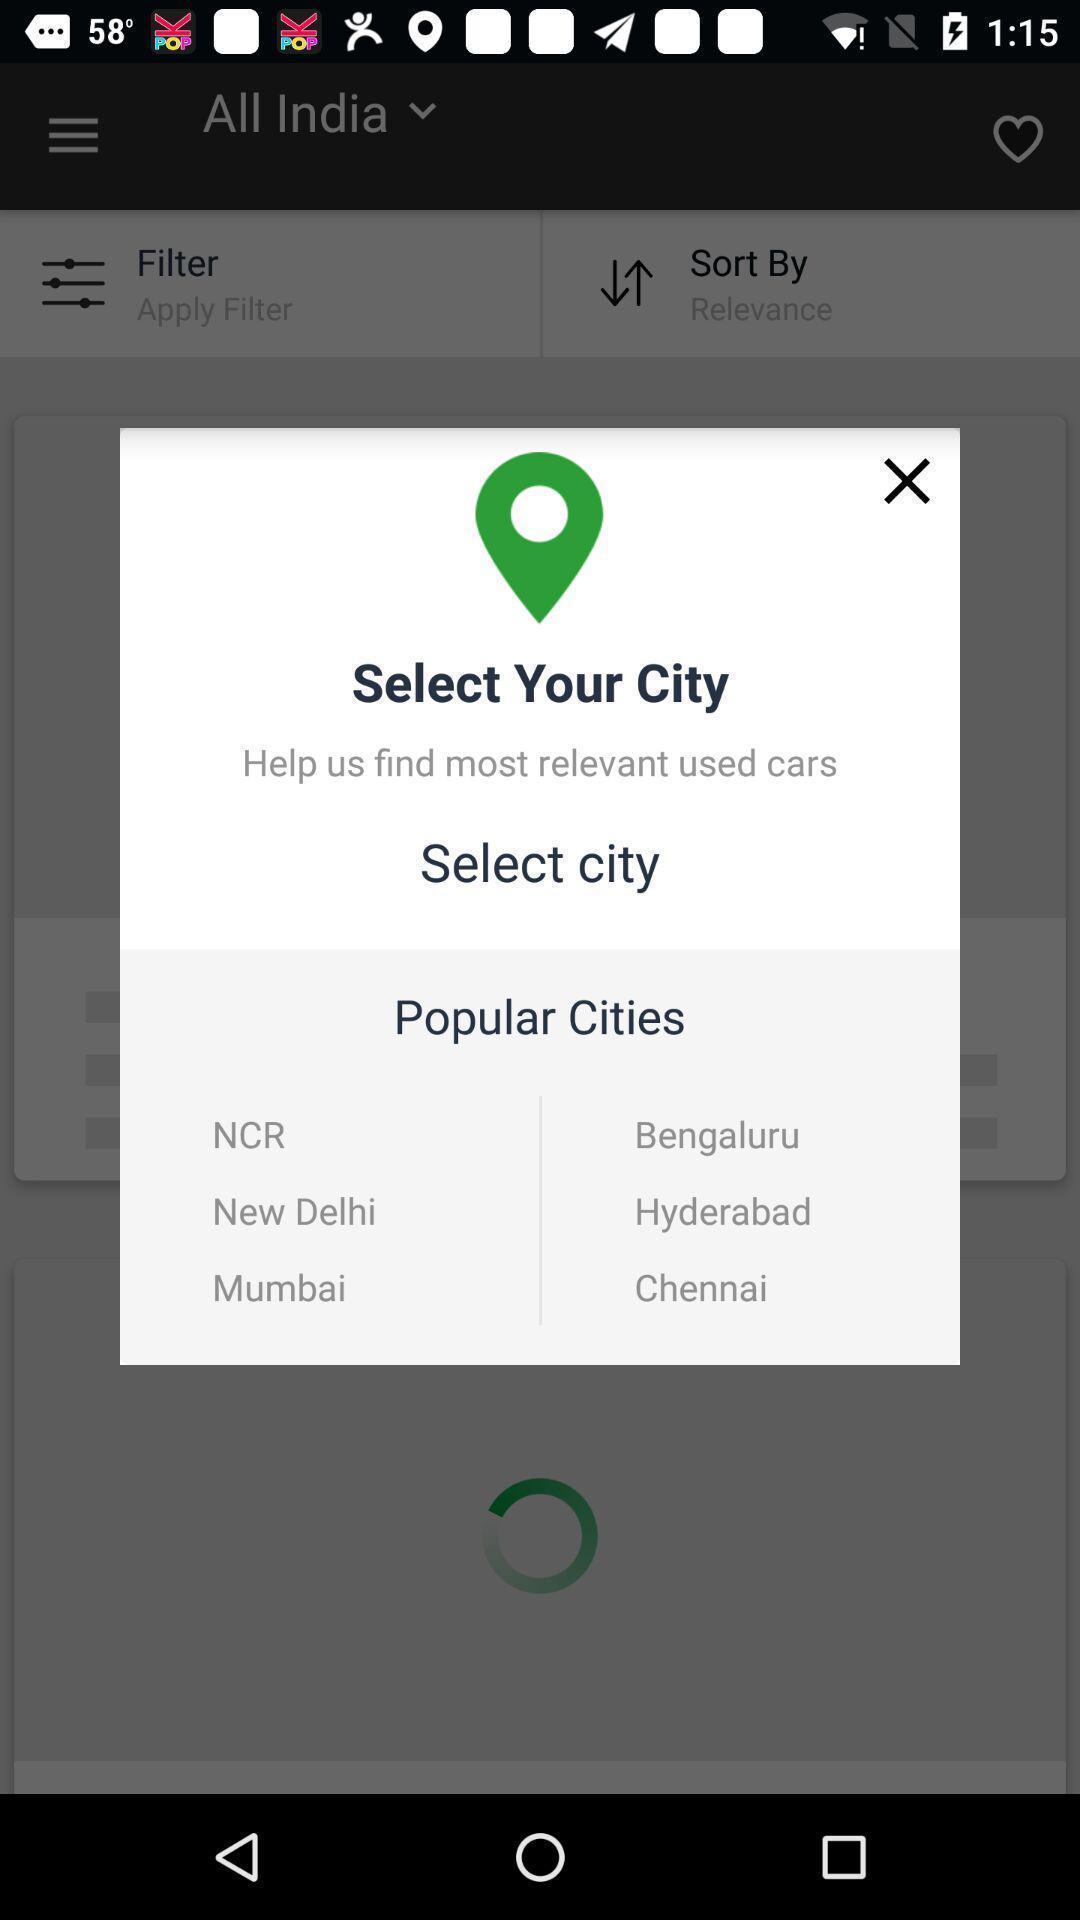Explain the elements present in this screenshot. Pop-up displaying cities to select. 